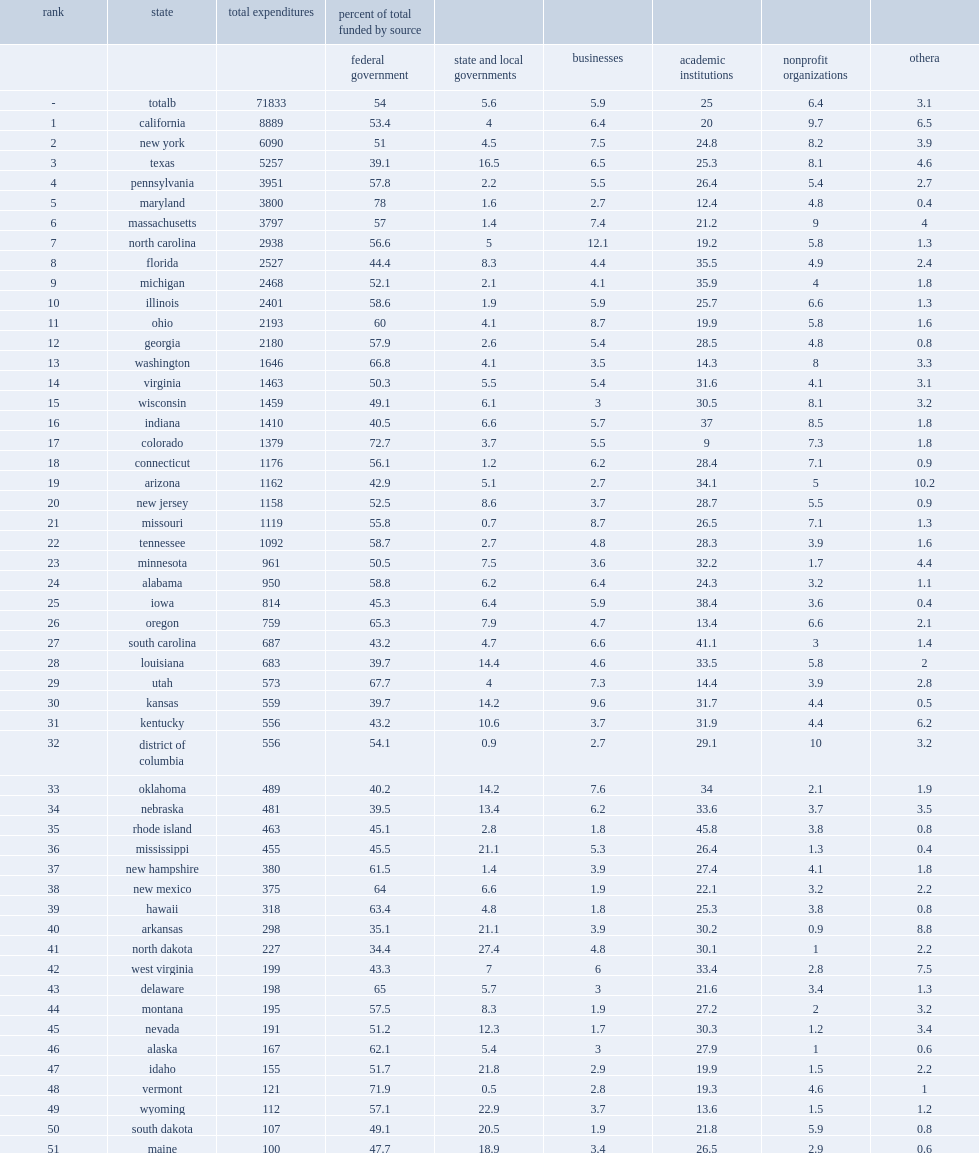How many percentage points of total academic r&d did the federal government fund in 2016? 54.0. How mnay percentage points did higher education institutions fund of total academic r&d in 2016? 25.0. 